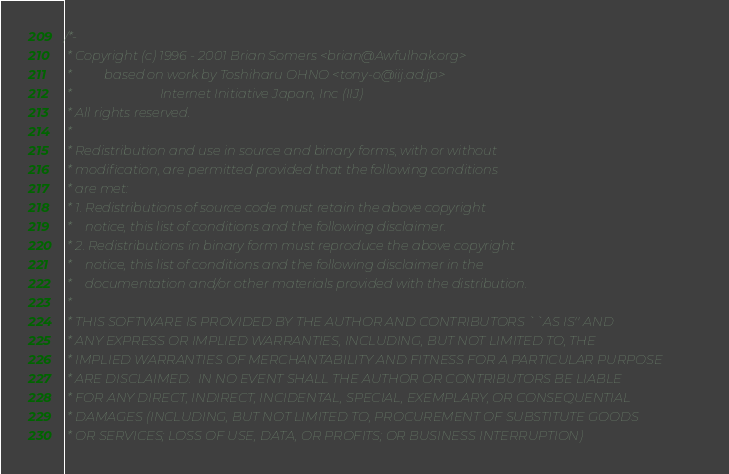Convert code to text. <code><loc_0><loc_0><loc_500><loc_500><_C_>/*-
 * Copyright (c) 1996 - 2001 Brian Somers <brian@Awfulhak.org>
 *          based on work by Toshiharu OHNO <tony-o@iij.ad.jp>
 *                           Internet Initiative Japan, Inc (IIJ)
 * All rights reserved.
 *
 * Redistribution and use in source and binary forms, with or without
 * modification, are permitted provided that the following conditions
 * are met:
 * 1. Redistributions of source code must retain the above copyright
 *    notice, this list of conditions and the following disclaimer.
 * 2. Redistributions in binary form must reproduce the above copyright
 *    notice, this list of conditions and the following disclaimer in the
 *    documentation and/or other materials provided with the distribution.
 *
 * THIS SOFTWARE IS PROVIDED BY THE AUTHOR AND CONTRIBUTORS ``AS IS'' AND
 * ANY EXPRESS OR IMPLIED WARRANTIES, INCLUDING, BUT NOT LIMITED TO, THE
 * IMPLIED WARRANTIES OF MERCHANTABILITY AND FITNESS FOR A PARTICULAR PURPOSE
 * ARE DISCLAIMED.  IN NO EVENT SHALL THE AUTHOR OR CONTRIBUTORS BE LIABLE
 * FOR ANY DIRECT, INDIRECT, INCIDENTAL, SPECIAL, EXEMPLARY, OR CONSEQUENTIAL
 * DAMAGES (INCLUDING, BUT NOT LIMITED TO, PROCUREMENT OF SUBSTITUTE GOODS
 * OR SERVICES; LOSS OF USE, DATA, OR PROFITS; OR BUSINESS INTERRUPTION)</code> 